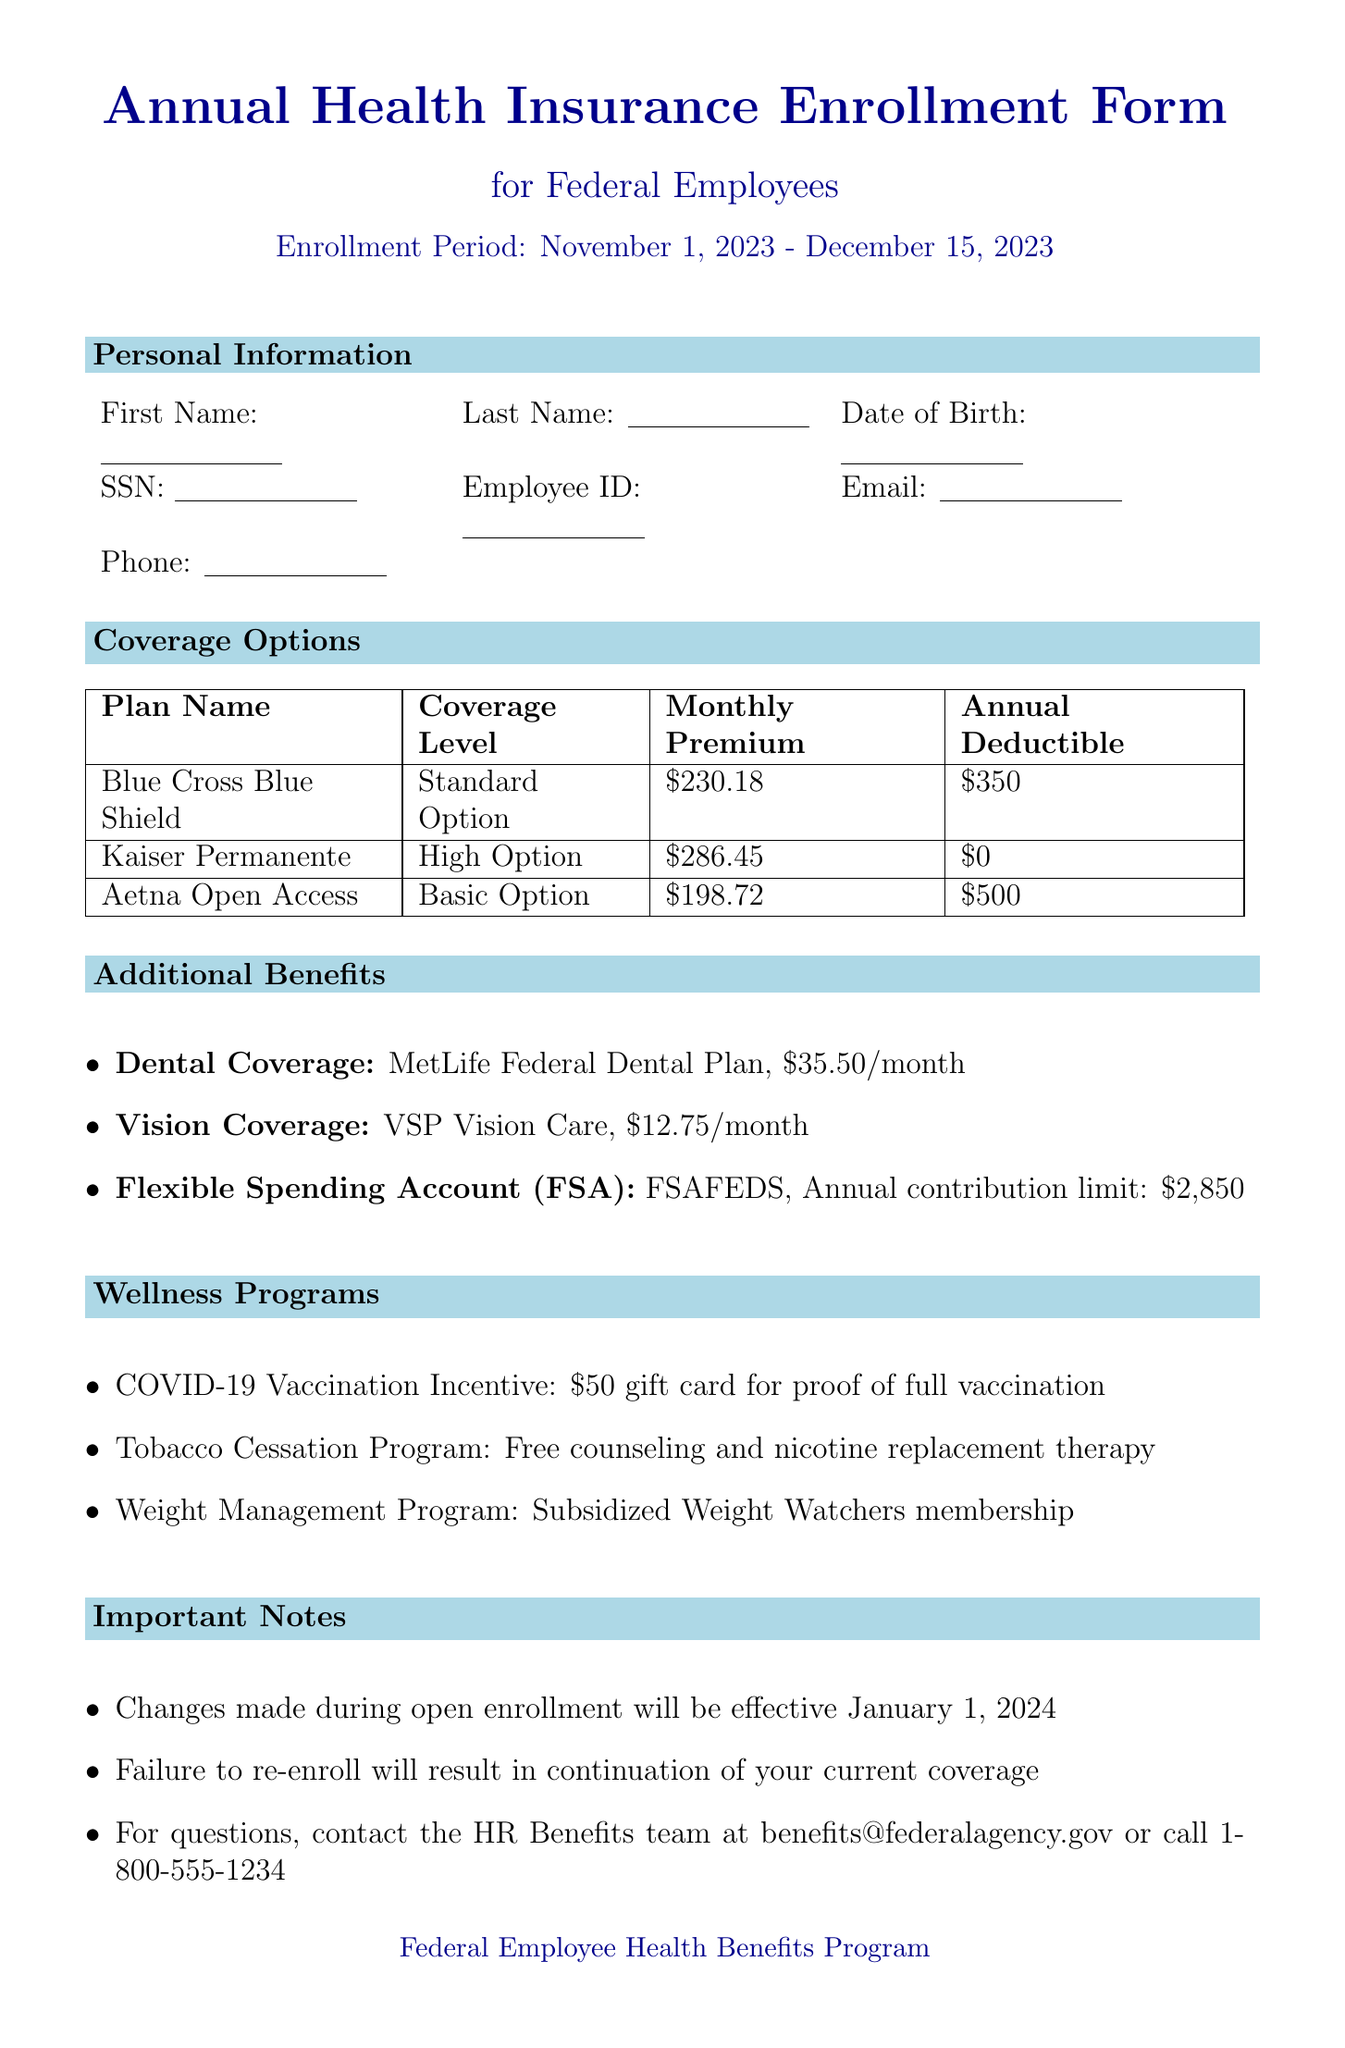what is the enrollment period for the health insurance? The enrollment period specified in the document is from November 1, 2023, to December 15, 2023.
Answer: November 1, 2023 - December 15, 2023 what is the monthly premium for the High Option plan? The document states that the monthly premium for the Kaiser Permanente Federal Health Benefits Plan, which is a High Option, is $286.45.
Answer: $286.45 how much is the annual deductible for the Standard Option plan? The annual deductible for the Blue Cross Blue Shield Federal Employee Program, which is the Standard Option, is $350 as mentioned in the document.
Answer: $350 how many visits does the Basic Option plan cover for mental health? The Aetna Open Access plan, categorized as the Basic Option, covers 25 visits per year for mental health according to the document.
Answer: 25 visits what is the benefit name associated with vision coverage? The document lists VSP Vision Care as the provider for vision coverage, hence the benefit name is Vision Coverage.
Answer: Vision Coverage what is the description of the COVID-19 Vaccination Incentive program? The document describes the COVID-19 Vaccination Incentive program as providing a $50 gift card for providing proof of full vaccination.
Answer: Receive a $50 gift card for providing proof of full COVID-19 vaccination what happens if you fail to re-enroll during the open enrollment period? According to the document, failure to re-enroll will result in the continuation of your current coverage.
Answer: Continuation of your current coverage what is the annual contribution limit for the Flexible Spending Account? The annual contribution limit for the Flexible Spending Account (FSA) as stated in the document is $2,850.
Answer: $2,850 how many visits per year are covered by the mental health benefit for the High Option plan? The Kaiser Permanente High Option plan provides unlimited visits for mental health coverage according to the document.
Answer: Unlimited visits 